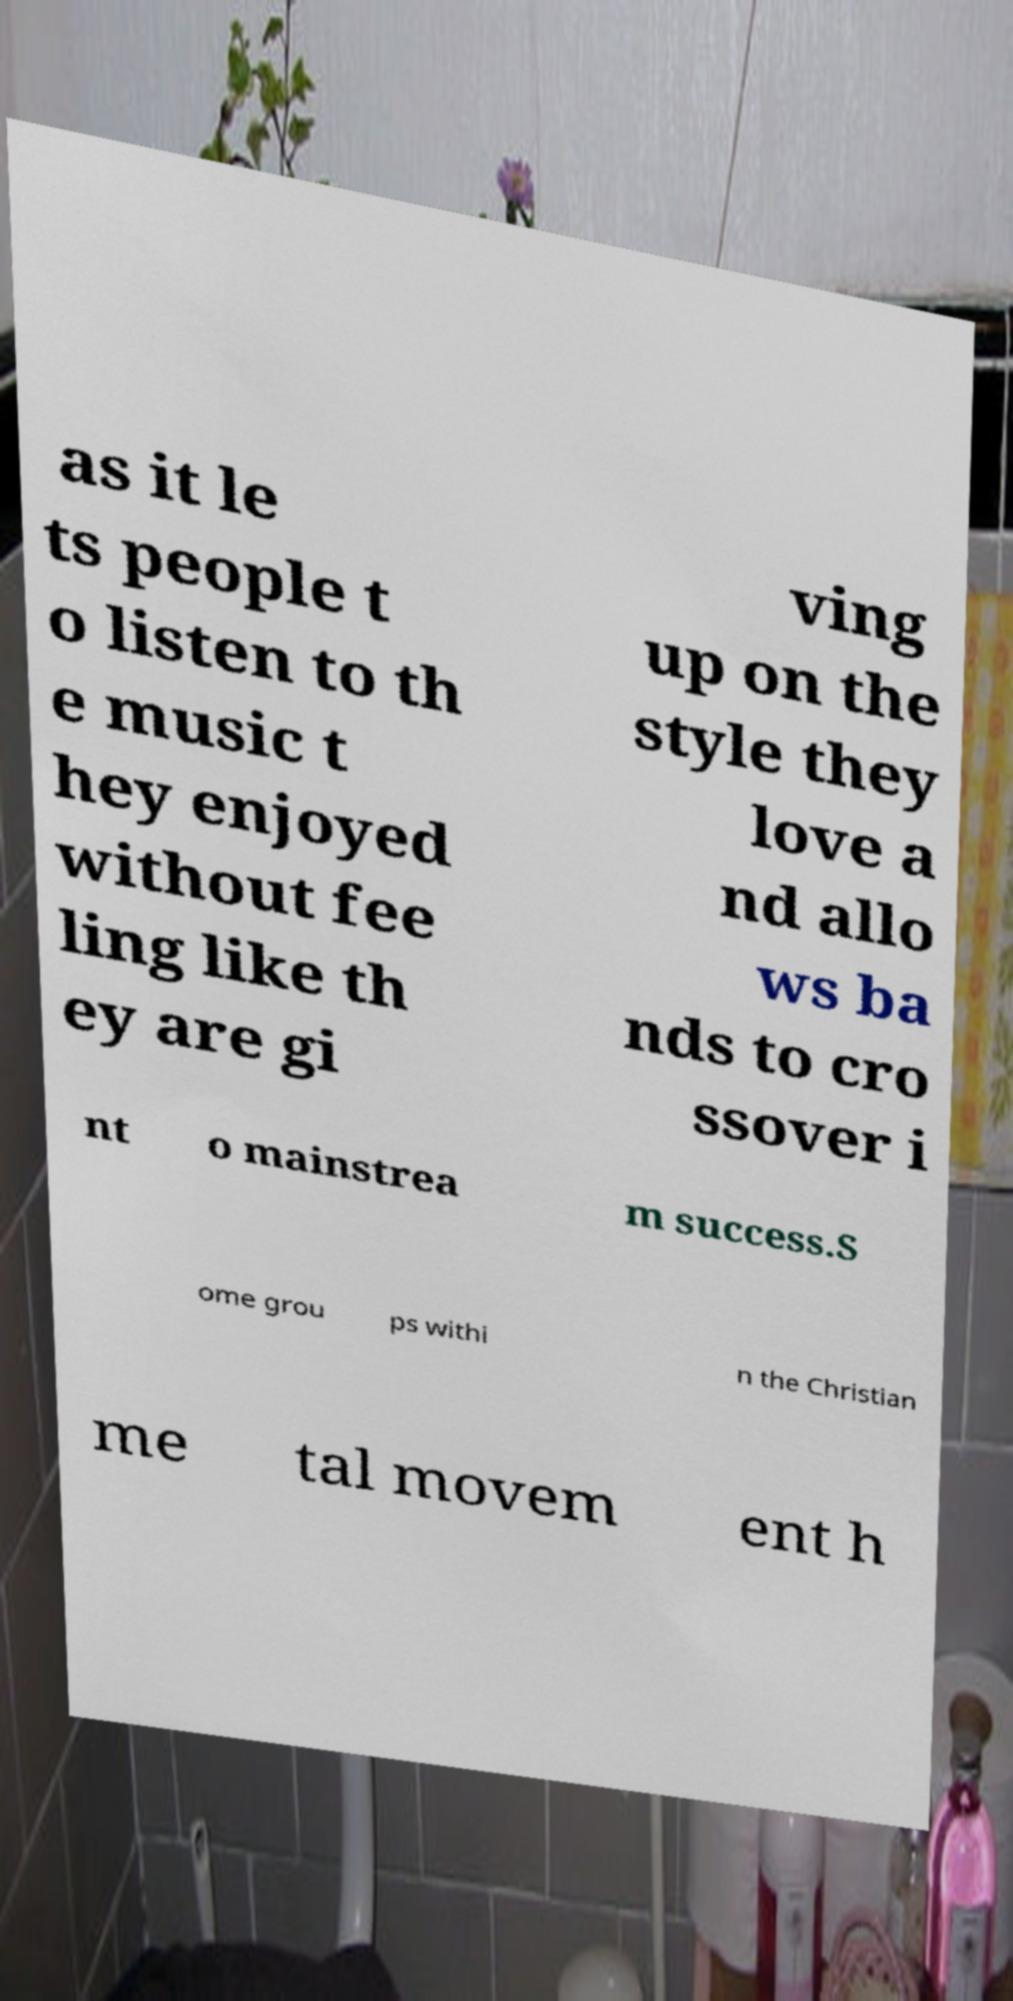Could you extract and type out the text from this image? as it le ts people t o listen to th e music t hey enjoyed without fee ling like th ey are gi ving up on the style they love a nd allo ws ba nds to cro ssover i nt o mainstrea m success.S ome grou ps withi n the Christian me tal movem ent h 